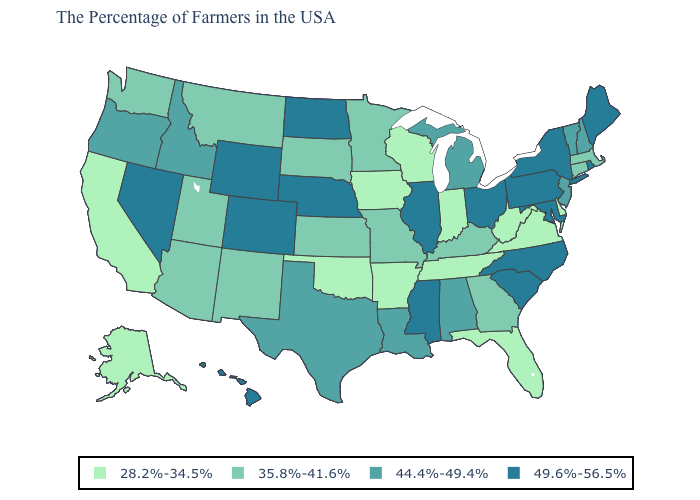How many symbols are there in the legend?
Answer briefly. 4. What is the value of West Virginia?
Give a very brief answer. 28.2%-34.5%. Which states have the highest value in the USA?
Be succinct. Maine, Rhode Island, New York, Maryland, Pennsylvania, North Carolina, South Carolina, Ohio, Illinois, Mississippi, Nebraska, North Dakota, Wyoming, Colorado, Nevada, Hawaii. What is the value of Arkansas?
Write a very short answer. 28.2%-34.5%. What is the highest value in the West ?
Give a very brief answer. 49.6%-56.5%. Does the map have missing data?
Concise answer only. No. What is the value of California?
Concise answer only. 28.2%-34.5%. What is the value of Arizona?
Give a very brief answer. 35.8%-41.6%. Does the first symbol in the legend represent the smallest category?
Answer briefly. Yes. What is the highest value in the South ?
Answer briefly. 49.6%-56.5%. What is the value of Alabama?
Quick response, please. 44.4%-49.4%. What is the lowest value in states that border Connecticut?
Give a very brief answer. 35.8%-41.6%. What is the value of New Hampshire?
Keep it brief. 44.4%-49.4%. Does Idaho have the lowest value in the West?
Be succinct. No. Name the states that have a value in the range 44.4%-49.4%?
Give a very brief answer. New Hampshire, Vermont, New Jersey, Michigan, Alabama, Louisiana, Texas, Idaho, Oregon. 